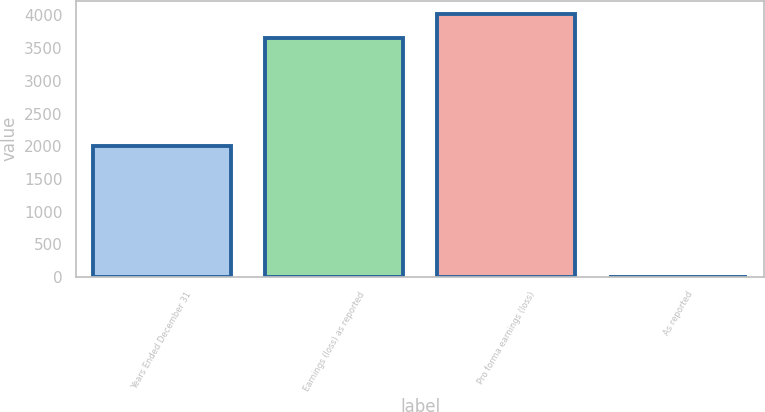<chart> <loc_0><loc_0><loc_500><loc_500><bar_chart><fcel>Years Ended December 31<fcel>Earnings (loss) as reported<fcel>Pro forma earnings (loss)<fcel>As reported<nl><fcel>2006<fcel>3661<fcel>4026.95<fcel>1.5<nl></chart> 